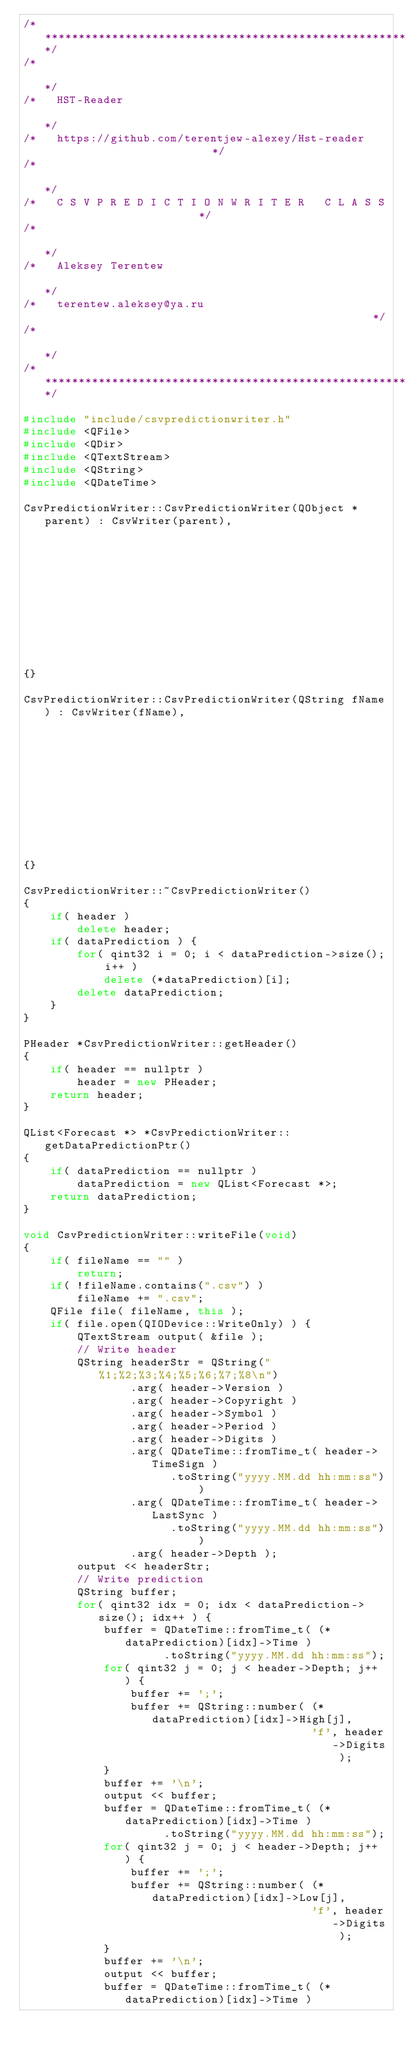<code> <loc_0><loc_0><loc_500><loc_500><_C++_>/*****************************************************************************/
/*                                                                           */
/*   HST-Reader                                                              */
/*   https://github.com/terentjew-alexey/Hst-reader                          */
/*                                                                           */
/*   C S V P R E D I C T I O N W R I T E R   C L A S S                       */
/*                                                                           */
/*   Aleksey Terentew                                                        */
/*   terentew.aleksey@ya.ru                                                  */
/*                                                                           */
/*****************************************************************************/

#include "include/csvpredictionwriter.h"
#include <QFile>
#include <QDir>
#include <QTextStream>
#include <QString>
#include <QDateTime>

CsvPredictionWriter::CsvPredictionWriter(QObject *parent) : CsvWriter(parent),
                                                            header(nullptr),
                                                            dataPrediction(nullptr)
{}

CsvPredictionWriter::CsvPredictionWriter(QString fName) : CsvWriter(fName),
                                                          header(nullptr),
                                                          dataPrediction(nullptr)
{}

CsvPredictionWriter::~CsvPredictionWriter()
{
    if( header )
        delete header;
    if( dataPrediction ) {
        for( qint32 i = 0; i < dataPrediction->size(); i++ )
            delete (*dataPrediction)[i];
        delete dataPrediction;
    }
}

PHeader *CsvPredictionWriter::getHeader()
{
    if( header == nullptr )
        header = new PHeader;
    return header;
}

QList<Forecast *> *CsvPredictionWriter::getDataPredictionPtr()
{
    if( dataPrediction == nullptr )
        dataPrediction = new QList<Forecast *>;
    return dataPrediction;
}

void CsvPredictionWriter::writeFile(void)
{
    if( fileName == "" )
        return;
    if( !fileName.contains(".csv") )
        fileName += ".csv";
    QFile file( fileName, this );
    if( file.open(QIODevice::WriteOnly) ) {
        QTextStream output( &file );
        // Write header
        QString headerStr = QString("%1;%2;%3;%4;%5;%6;%7;%8\n")
                .arg( header->Version )
                .arg( header->Copyright )
                .arg( header->Symbol )
                .arg( header->Period )
                .arg( header->Digits )
                .arg( QDateTime::fromTime_t( header->TimeSign )
                      .toString("yyyy.MM.dd hh:mm:ss") )
                .arg( QDateTime::fromTime_t( header->LastSync )
                      .toString("yyyy.MM.dd hh:mm:ss") )
                .arg( header->Depth );
        output << headerStr;
        // Write prediction
        QString buffer;
        for( qint32 idx = 0; idx < dataPrediction->size(); idx++ ) {
            buffer = QDateTime::fromTime_t( (*dataPrediction)[idx]->Time )
                     .toString("yyyy.MM.dd hh:mm:ss");
            for( qint32 j = 0; j < header->Depth; j++ ) {
                buffer += ';';
                buffer += QString::number( (*dataPrediction)[idx]->High[j],
                                           'f', header->Digits );
            }
            buffer += '\n';
            output << buffer;
            buffer = QDateTime::fromTime_t( (*dataPrediction)[idx]->Time )
                     .toString("yyyy.MM.dd hh:mm:ss");
            for( qint32 j = 0; j < header->Depth; j++ ) {
                buffer += ';';
                buffer += QString::number( (*dataPrediction)[idx]->Low[j],
                                           'f', header->Digits );
            }
            buffer += '\n';
            output << buffer;
            buffer = QDateTime::fromTime_t( (*dataPrediction)[idx]->Time )</code> 